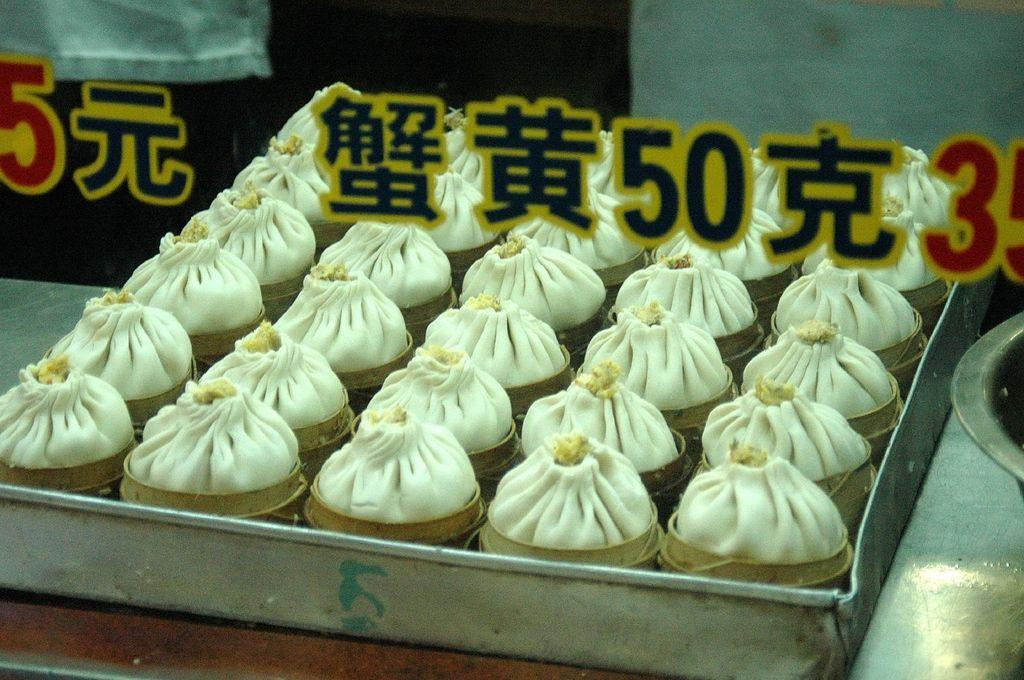What type of objects can be seen in the image? There are food items in the image. How are the food items arranged or contained? The food items are in a tray. Where is the tray with food items located? The tray is on a table. Can you read any text in the image? Yes, there is text visible on a glass in the image. What type of polish is being applied to the jeans in the image? There are no jeans or polish present in the image; it only features food items in a tray on a table and text on a glass. 